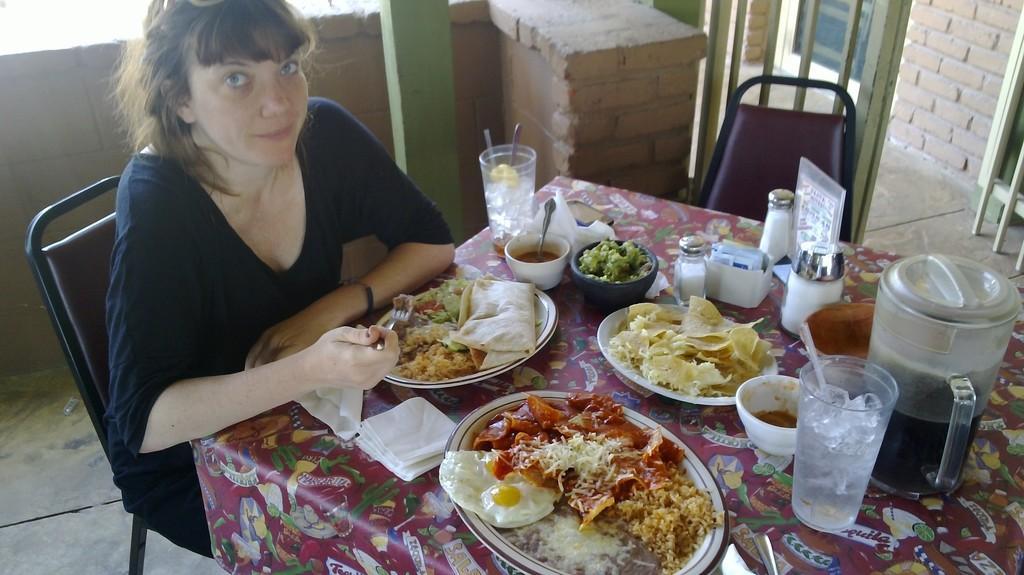Describe this image in one or two sentences. In this image I can see there is a lady sitting on chair in-front of table where we can see there are so many food items served in plate and bowls, also there are glasses with ice cubes and jars, beside her there is a empty chair and at the back there is a pillar and wall. 